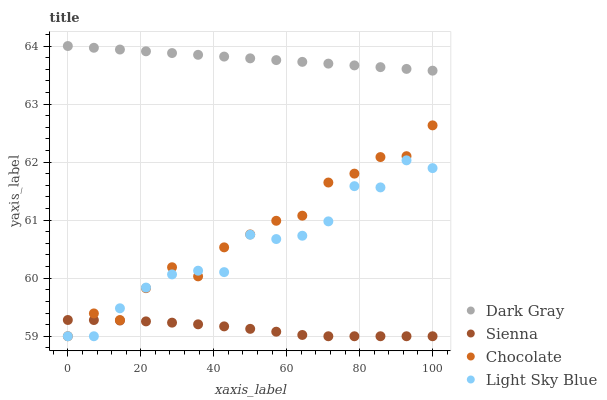Does Sienna have the minimum area under the curve?
Answer yes or no. Yes. Does Dark Gray have the maximum area under the curve?
Answer yes or no. Yes. Does Light Sky Blue have the minimum area under the curve?
Answer yes or no. No. Does Light Sky Blue have the maximum area under the curve?
Answer yes or no. No. Is Dark Gray the smoothest?
Answer yes or no. Yes. Is Chocolate the roughest?
Answer yes or no. Yes. Is Sienna the smoothest?
Answer yes or no. No. Is Sienna the roughest?
Answer yes or no. No. Does Sienna have the lowest value?
Answer yes or no. Yes. Does Dark Gray have the highest value?
Answer yes or no. Yes. Does Light Sky Blue have the highest value?
Answer yes or no. No. Is Chocolate less than Dark Gray?
Answer yes or no. Yes. Is Dark Gray greater than Light Sky Blue?
Answer yes or no. Yes. Does Light Sky Blue intersect Chocolate?
Answer yes or no. Yes. Is Light Sky Blue less than Chocolate?
Answer yes or no. No. Is Light Sky Blue greater than Chocolate?
Answer yes or no. No. Does Chocolate intersect Dark Gray?
Answer yes or no. No. 